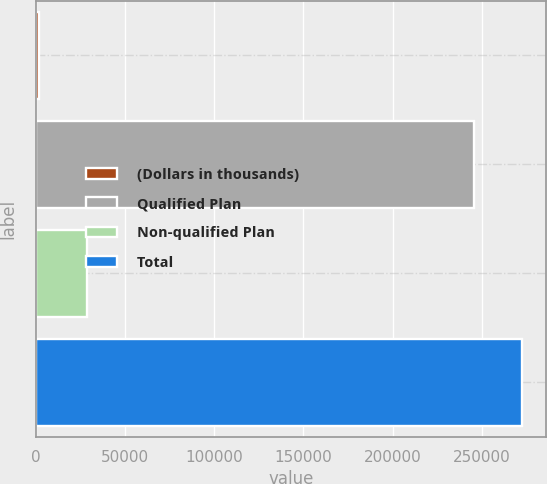<chart> <loc_0><loc_0><loc_500><loc_500><bar_chart><fcel>(Dollars in thousands)<fcel>Qualified Plan<fcel>Non-qualified Plan<fcel>Total<nl><fcel>2017<fcel>245430<fcel>28806.5<fcel>272220<nl></chart> 